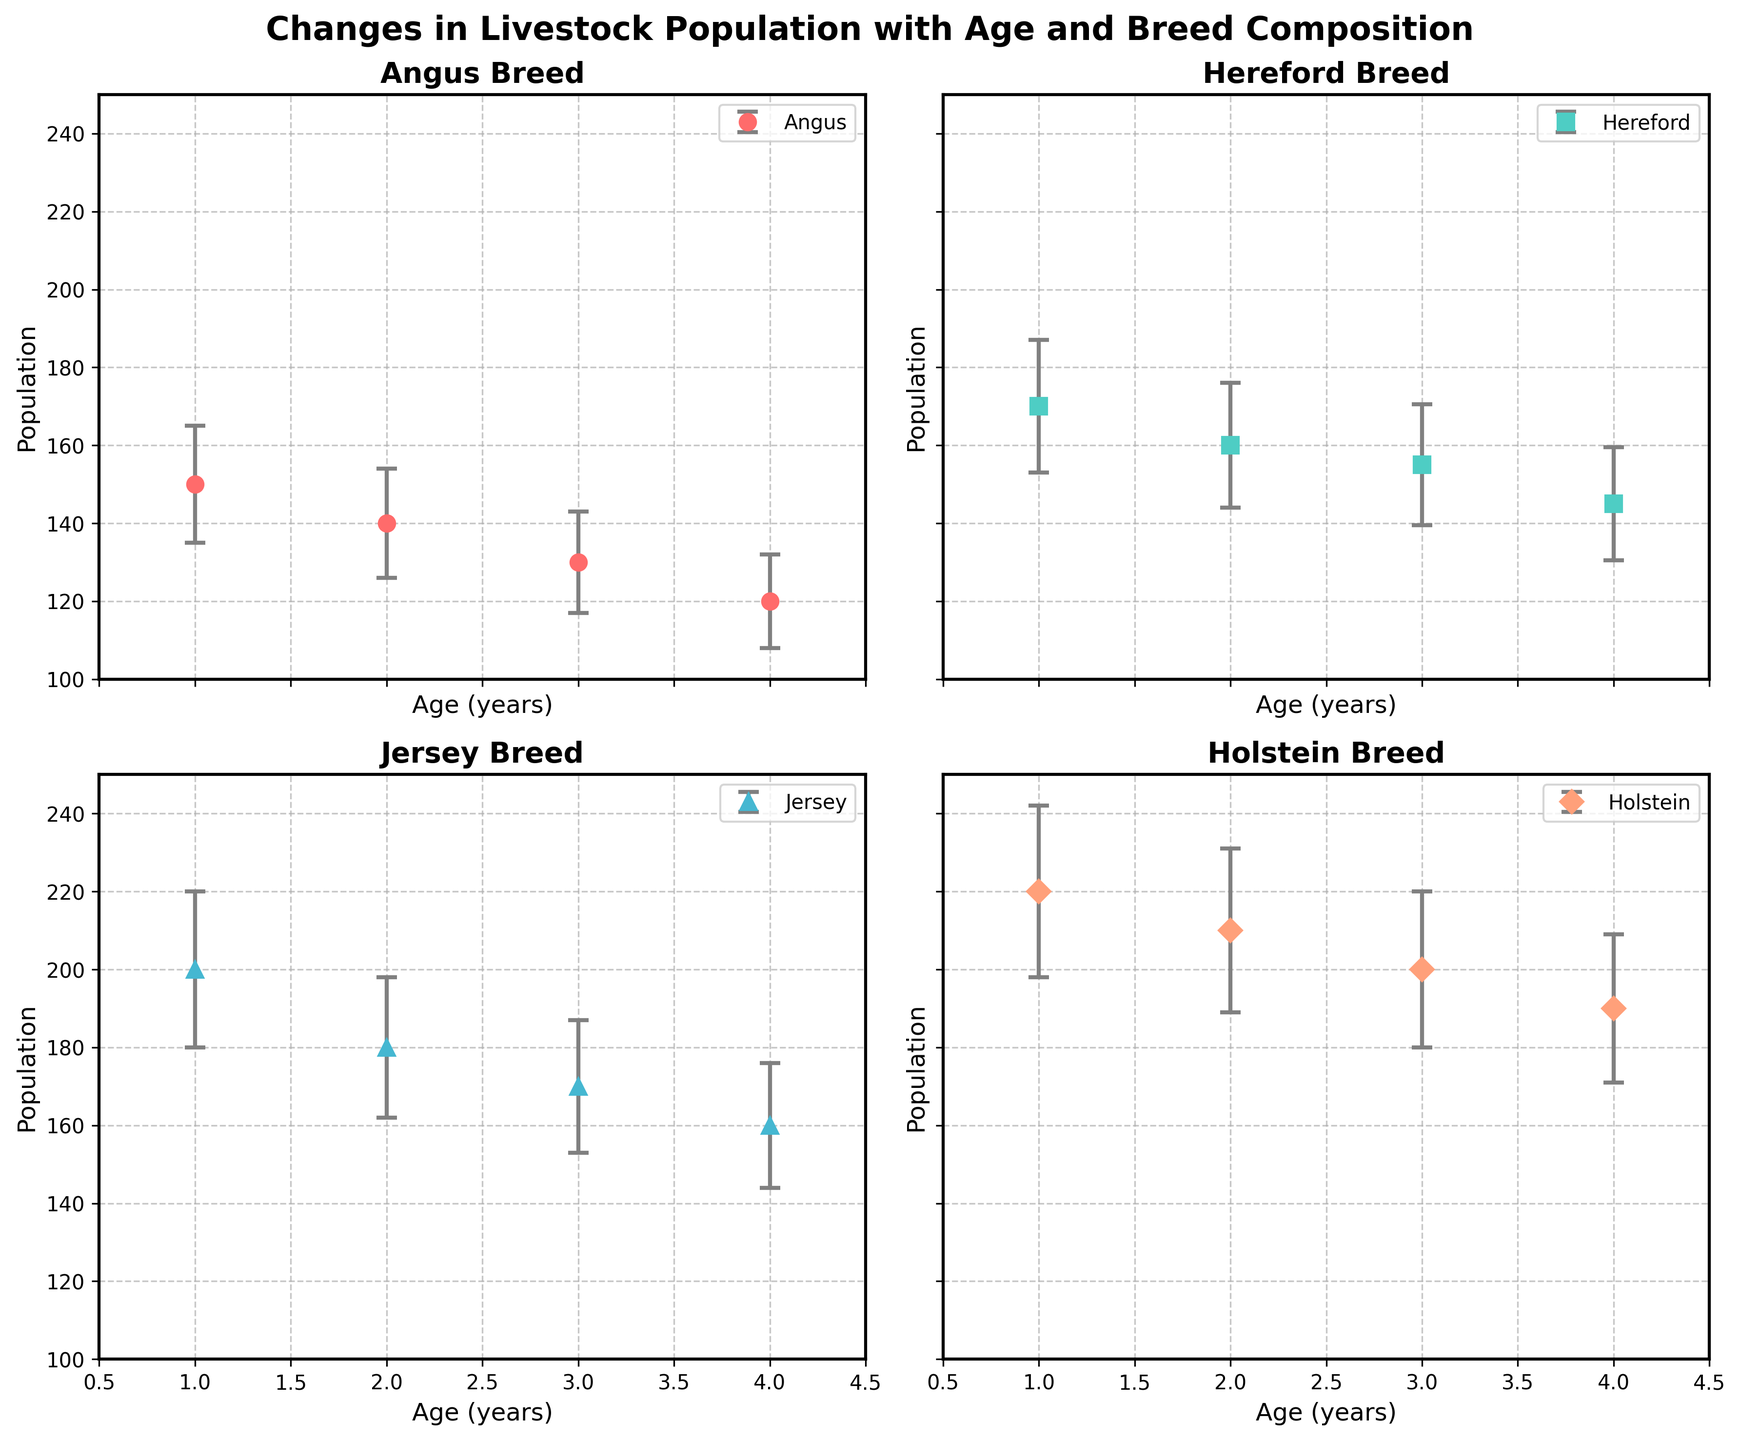How many breeds are displayed in the figure? The figure shows four subplots, one for each breed. Each subplot is titled with the respective breed name.
Answer: Four What is the population trend for Jersey breed over the ages? By looking at the subplot for the Jersey breed, the population decreases consistently from 200 at age 1 to 160 at age 4.
Answer: Decreasing What age shows the highest population for the Holstein breed? In the subplot for Holstein breed, the highest population is at age 1 with a value of 220.
Answer: Age 1 Compare the population standard deviation of Angus breed at age 1 and age 3. Which is higher? In the Angus breed subplot, the standard deviation at age 1 is 15 and at age 3 it is 13. So, the standard deviation is higher at age 1.
Answer: Age 1 Which breed has the largest population at age 2? By comparing the subplots, at age 2, Holstein has the largest population with a value of 210.
Answer: Holstein How does the Hereford breed's population change between age 2 and age 3? In the Hereford breed subplot, the population slightly decreases from 160 at age 2 to 155 at age 3.
Answer: Decreases slightly What's the average population of the Angus breed across all ages? For the Angus breed, the populations are 150, 140, 130, and 120 respectively. Adding these values gives 540, and the average is 540/4 = 135.
Answer: 135 Which breed has the smallest population at age 3 and what is it? Comparing the subplots for age 3, Angus has the smallest population with a value of 130.
Answer: Angus, 130 Is there any breed whose population increases with age? Looking at the trends in all subplots, none of the breeds show an increasing population with age; they all decrease.
Answer: No 